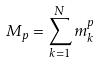Convert formula to latex. <formula><loc_0><loc_0><loc_500><loc_500>M _ { p } = \sum _ { k = 1 } ^ { N } m _ { k } ^ { p }</formula> 